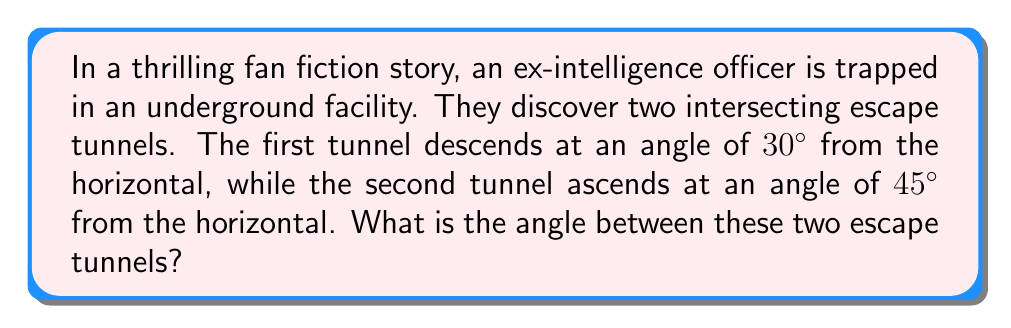Provide a solution to this math problem. Let's approach this step-by-step:

1) First, we need to visualize the problem. The two tunnels can be represented as lines in a vertical plane, with the horizontal as a reference line.

2) Let's define our angles:
   - Tunnel 1 makes a 30° angle below the horizontal
   - Tunnel 2 makes a 45° angle above the horizontal

3) To find the angle between the tunnels, we need to add these two angles:

   $$\text{Angle between tunnels} = 30° + 45° = 75°$$

4) However, this is not our final answer. In solid geometry, the angle between two lines (or in this case, tunnels) is defined as the acute angle between them.

5) The acute angle is always less than or equal to 90°. If our calculated angle is greater than 90°, we need to subtract it from 180° to get the acute angle.

6) In this case, 75° is already an acute angle, so it's our final answer.

[asy]
import geometry;

size(200);
pair O=(0,0);
pair A=(-100,-57.735);
pair B=(100,100);

draw(A--O--B);
draw((-120,0)--(120,0),dashed);

label("30°",(-50,-20),NE);
label("45°",(50,40),NW);
label("75°",(0,0),E);

dot(O);
[/asy]
Answer: 75° 